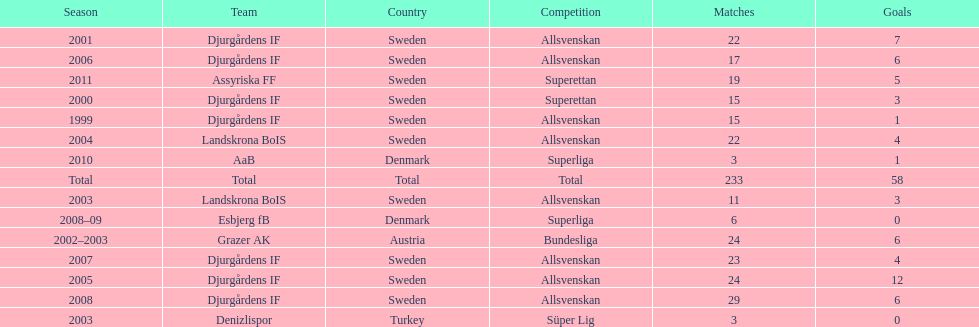How many matches overall were there? 233. 